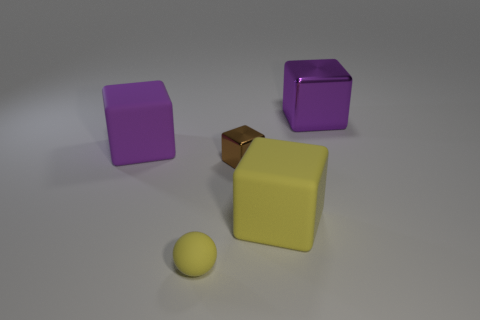How many large things are either brown metallic things or brown matte objects?
Your answer should be very brief. 0. What number of other purple things have the same shape as the purple metallic thing?
Make the answer very short. 1. There is a small metal thing; is its shape the same as the large matte thing to the left of the brown object?
Give a very brief answer. Yes. There is a purple metal object; what number of purple rubber objects are behind it?
Give a very brief answer. 0. Are there any gray blocks that have the same size as the brown shiny object?
Ensure brevity in your answer.  No. Does the large matte thing left of the big yellow block have the same shape as the small yellow rubber object?
Your answer should be very brief. No. What color is the small matte sphere?
Ensure brevity in your answer.  Yellow. What shape is the other big object that is the same color as the big metal thing?
Your answer should be very brief. Cube. Are any shiny objects visible?
Make the answer very short. Yes. What is the size of the purple object that is the same material as the tiny brown block?
Offer a terse response. Large. 